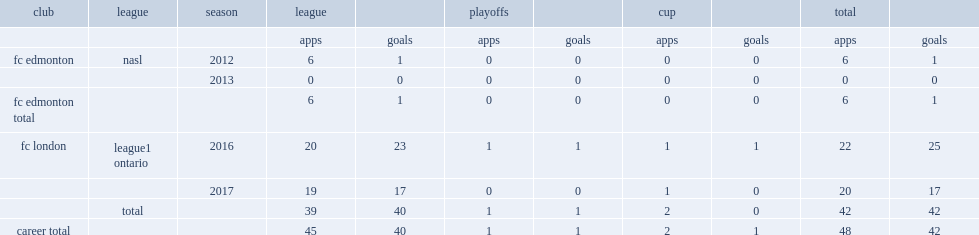Which club did gigolaj play for in 2016-17? Fc london. 